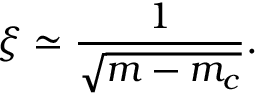<formula> <loc_0><loc_0><loc_500><loc_500>\xi \simeq \frac { 1 } { \sqrt { m - m _ { c } } } .</formula> 